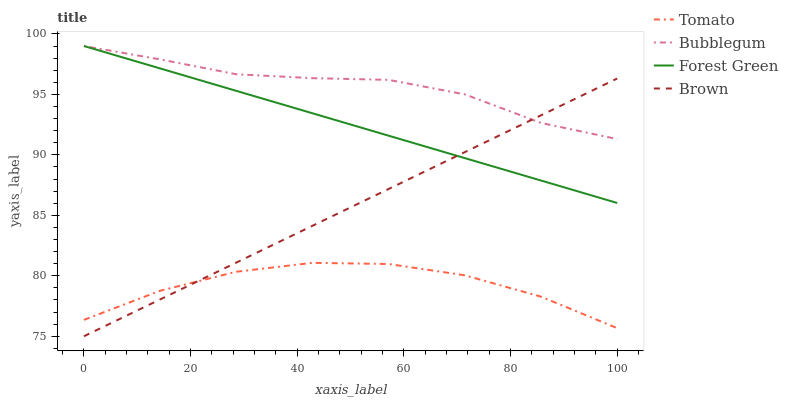Does Tomato have the minimum area under the curve?
Answer yes or no. Yes. Does Bubblegum have the maximum area under the curve?
Answer yes or no. Yes. Does Brown have the minimum area under the curve?
Answer yes or no. No. Does Brown have the maximum area under the curve?
Answer yes or no. No. Is Forest Green the smoothest?
Answer yes or no. Yes. Is Tomato the roughest?
Answer yes or no. Yes. Is Brown the smoothest?
Answer yes or no. No. Is Brown the roughest?
Answer yes or no. No. Does Forest Green have the lowest value?
Answer yes or no. No. Does Bubblegum have the highest value?
Answer yes or no. Yes. Does Brown have the highest value?
Answer yes or no. No. Is Tomato less than Bubblegum?
Answer yes or no. Yes. Is Bubblegum greater than Tomato?
Answer yes or no. Yes. Does Brown intersect Forest Green?
Answer yes or no. Yes. Is Brown less than Forest Green?
Answer yes or no. No. Is Brown greater than Forest Green?
Answer yes or no. No. Does Tomato intersect Bubblegum?
Answer yes or no. No. 